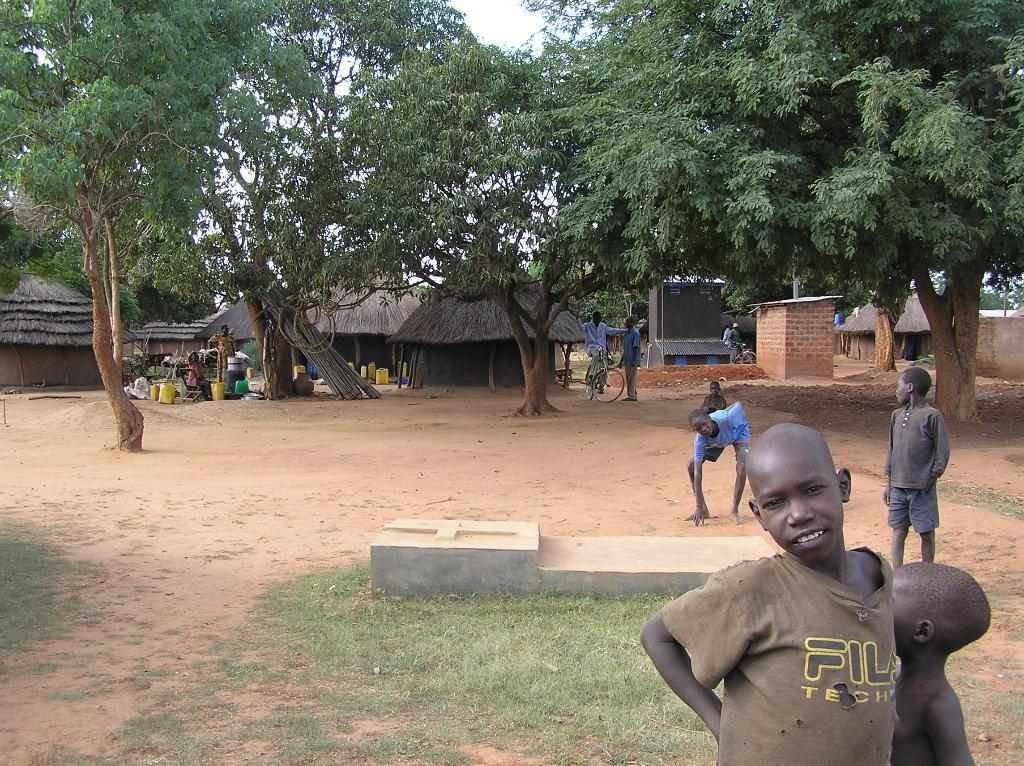How many people are in the group visible in the image? The number of people in the group cannot be determined from the provided facts. What type of vegetation is present in the image? There are trees in the image. What type of structures can be seen in the background of the image? In the background of the image, there are huts. What mode of transportation is visible in the background of the image? Bicycles are present in the background of the image. What type of cable is being used to support the net in the image? There is no cable or net present in the image. What type of car can be seen in the image? There is no car present in the image. 